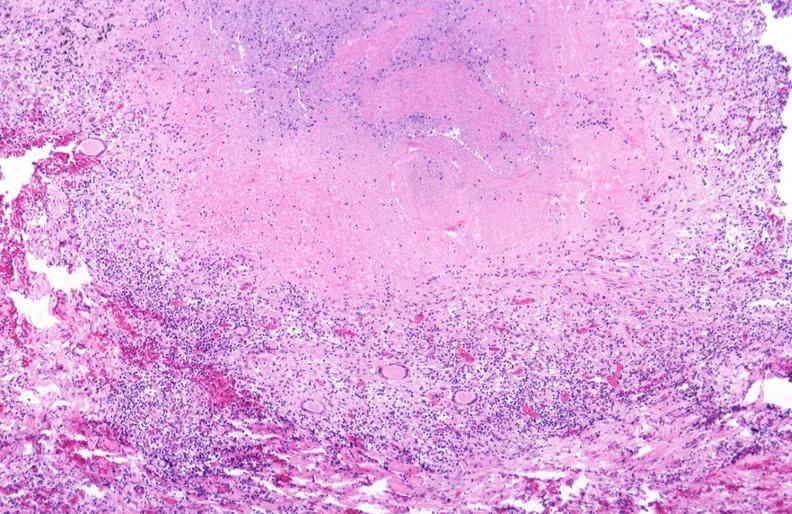s respiratory present?
Answer the question using a single word or phrase. Yes 